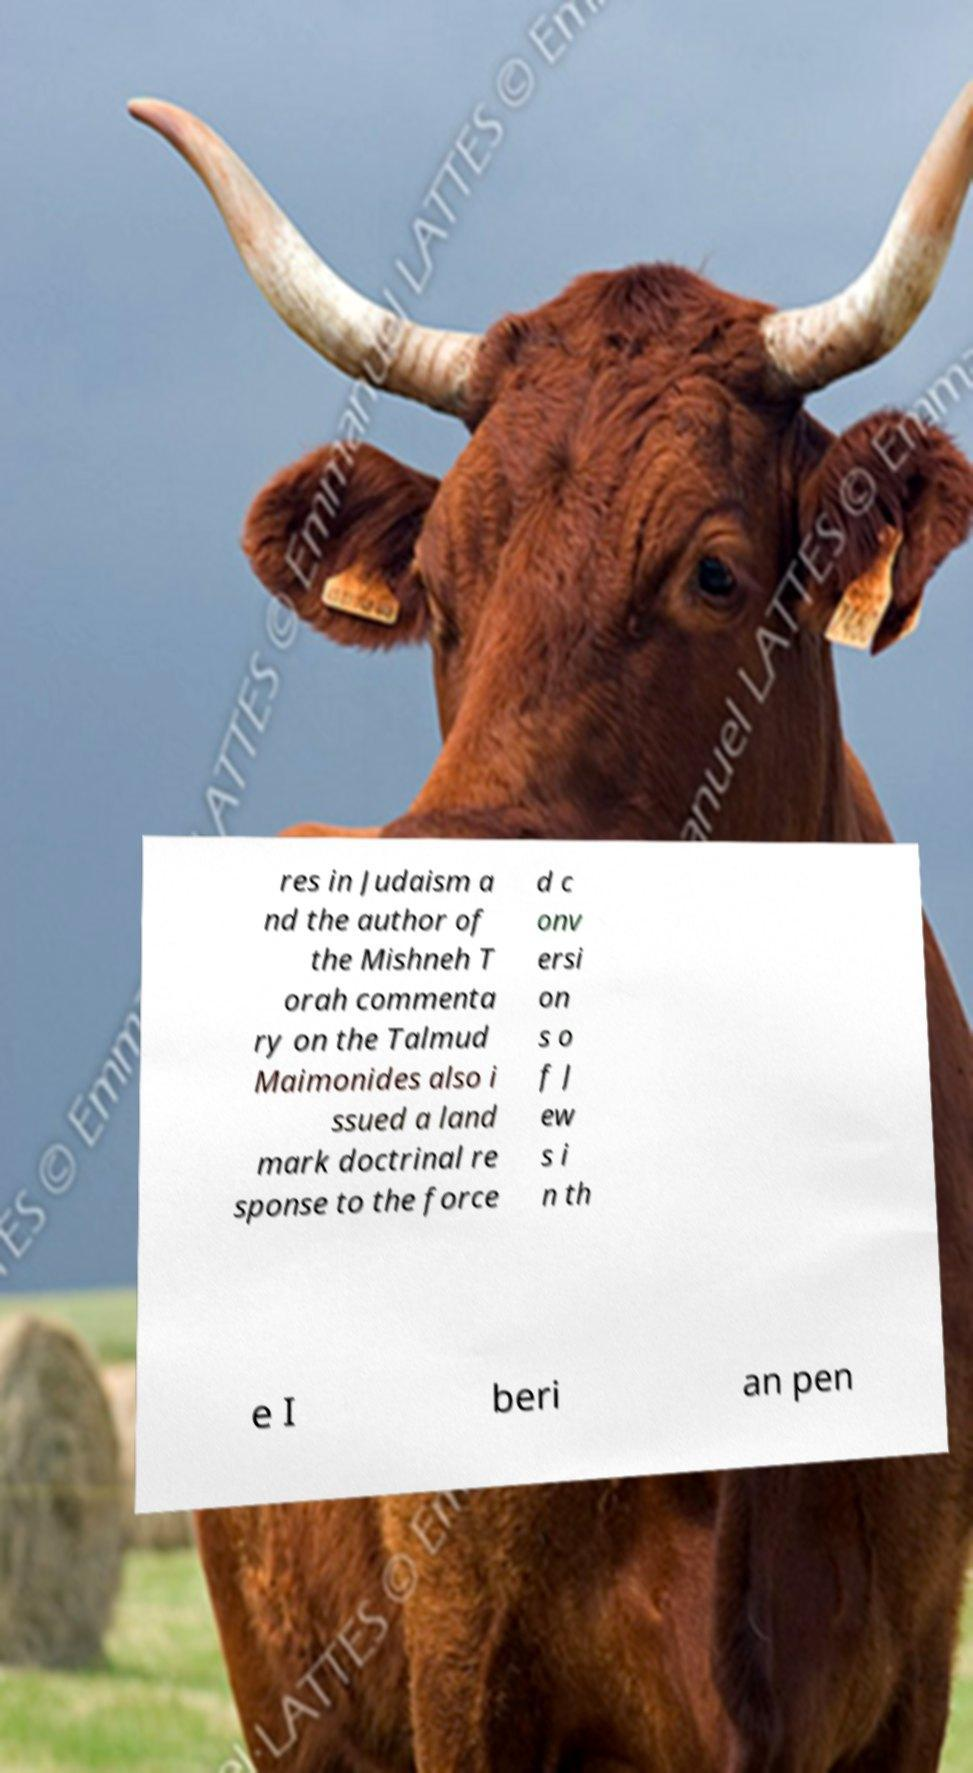I need the written content from this picture converted into text. Can you do that? res in Judaism a nd the author of the Mishneh T orah commenta ry on the Talmud Maimonides also i ssued a land mark doctrinal re sponse to the force d c onv ersi on s o f J ew s i n th e I beri an pen 